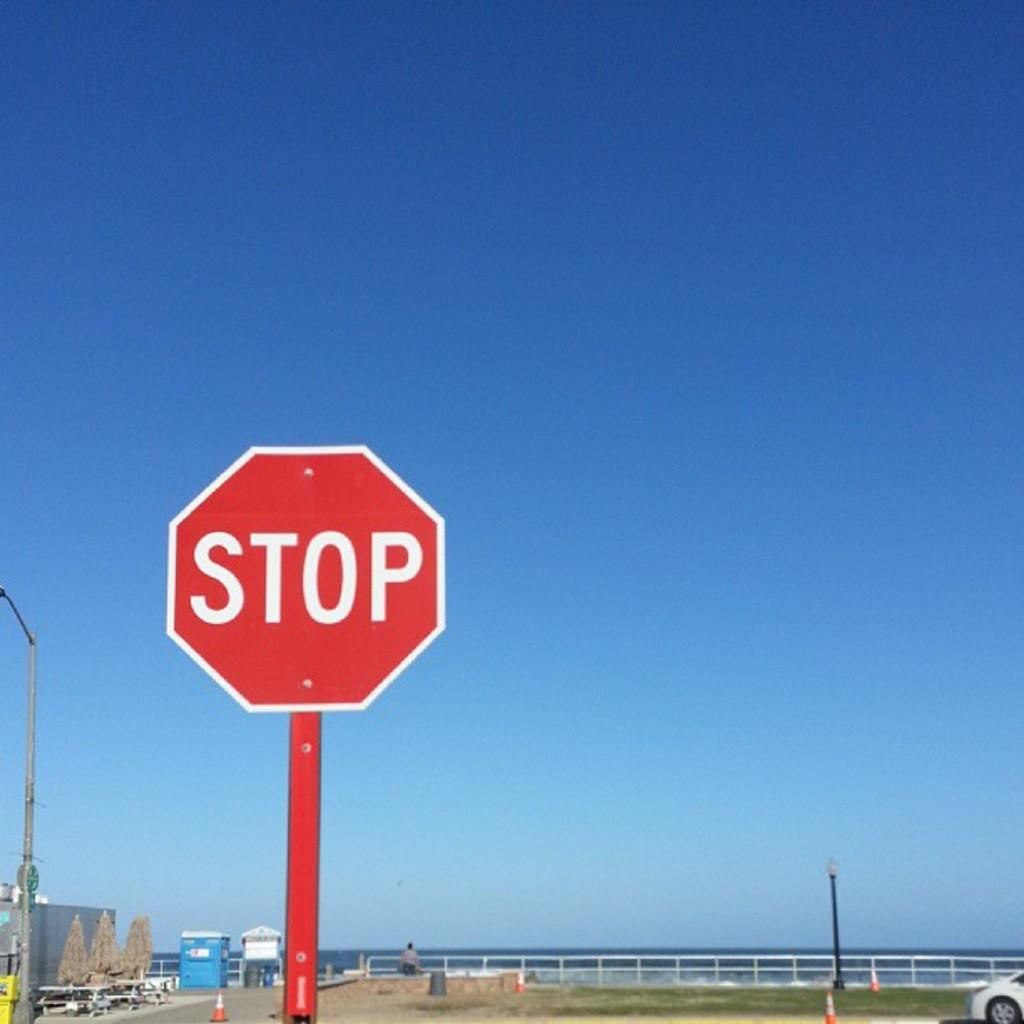Provide a one-sentence caption for the provided image. A octagon sign and a red pole with STOP in white lettering. 